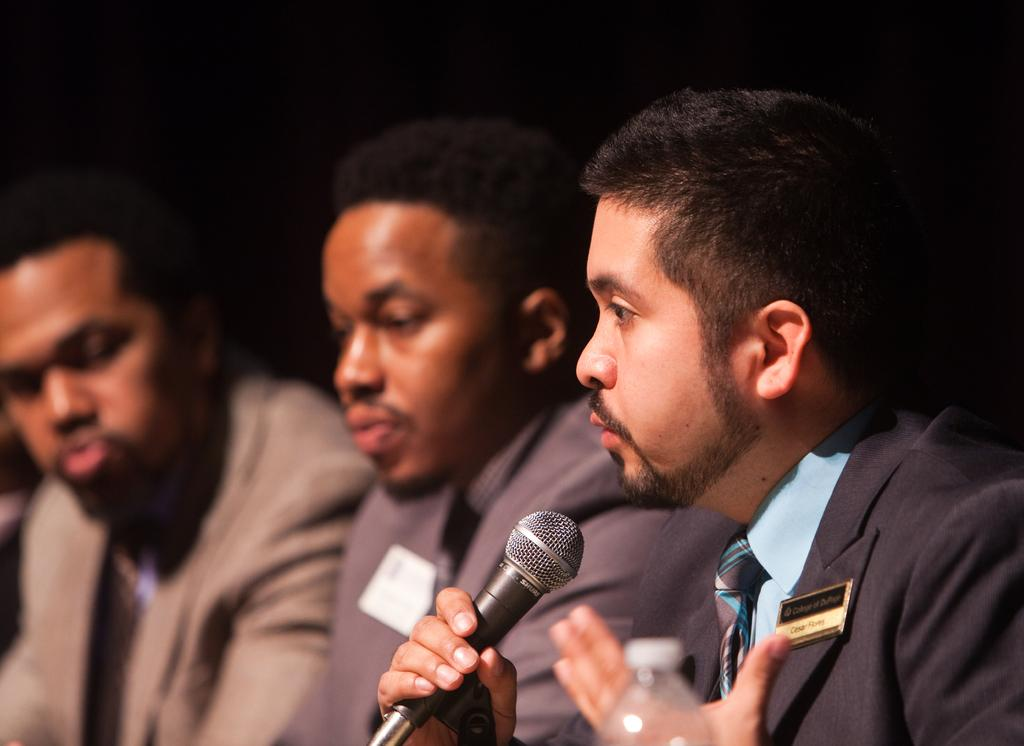What are the people in the image doing? The people in the image are sitting. What object is the man holding in the image? The man is holding a microphone in the image. What is the color of the microphone? The microphone is black in color. What is the man doing with the microphone? The man is speaking into the microphone. Are there any children playing with art supplies in the image? There is no mention of children or art supplies in the image; it features people sitting and a man holding a microphone. 